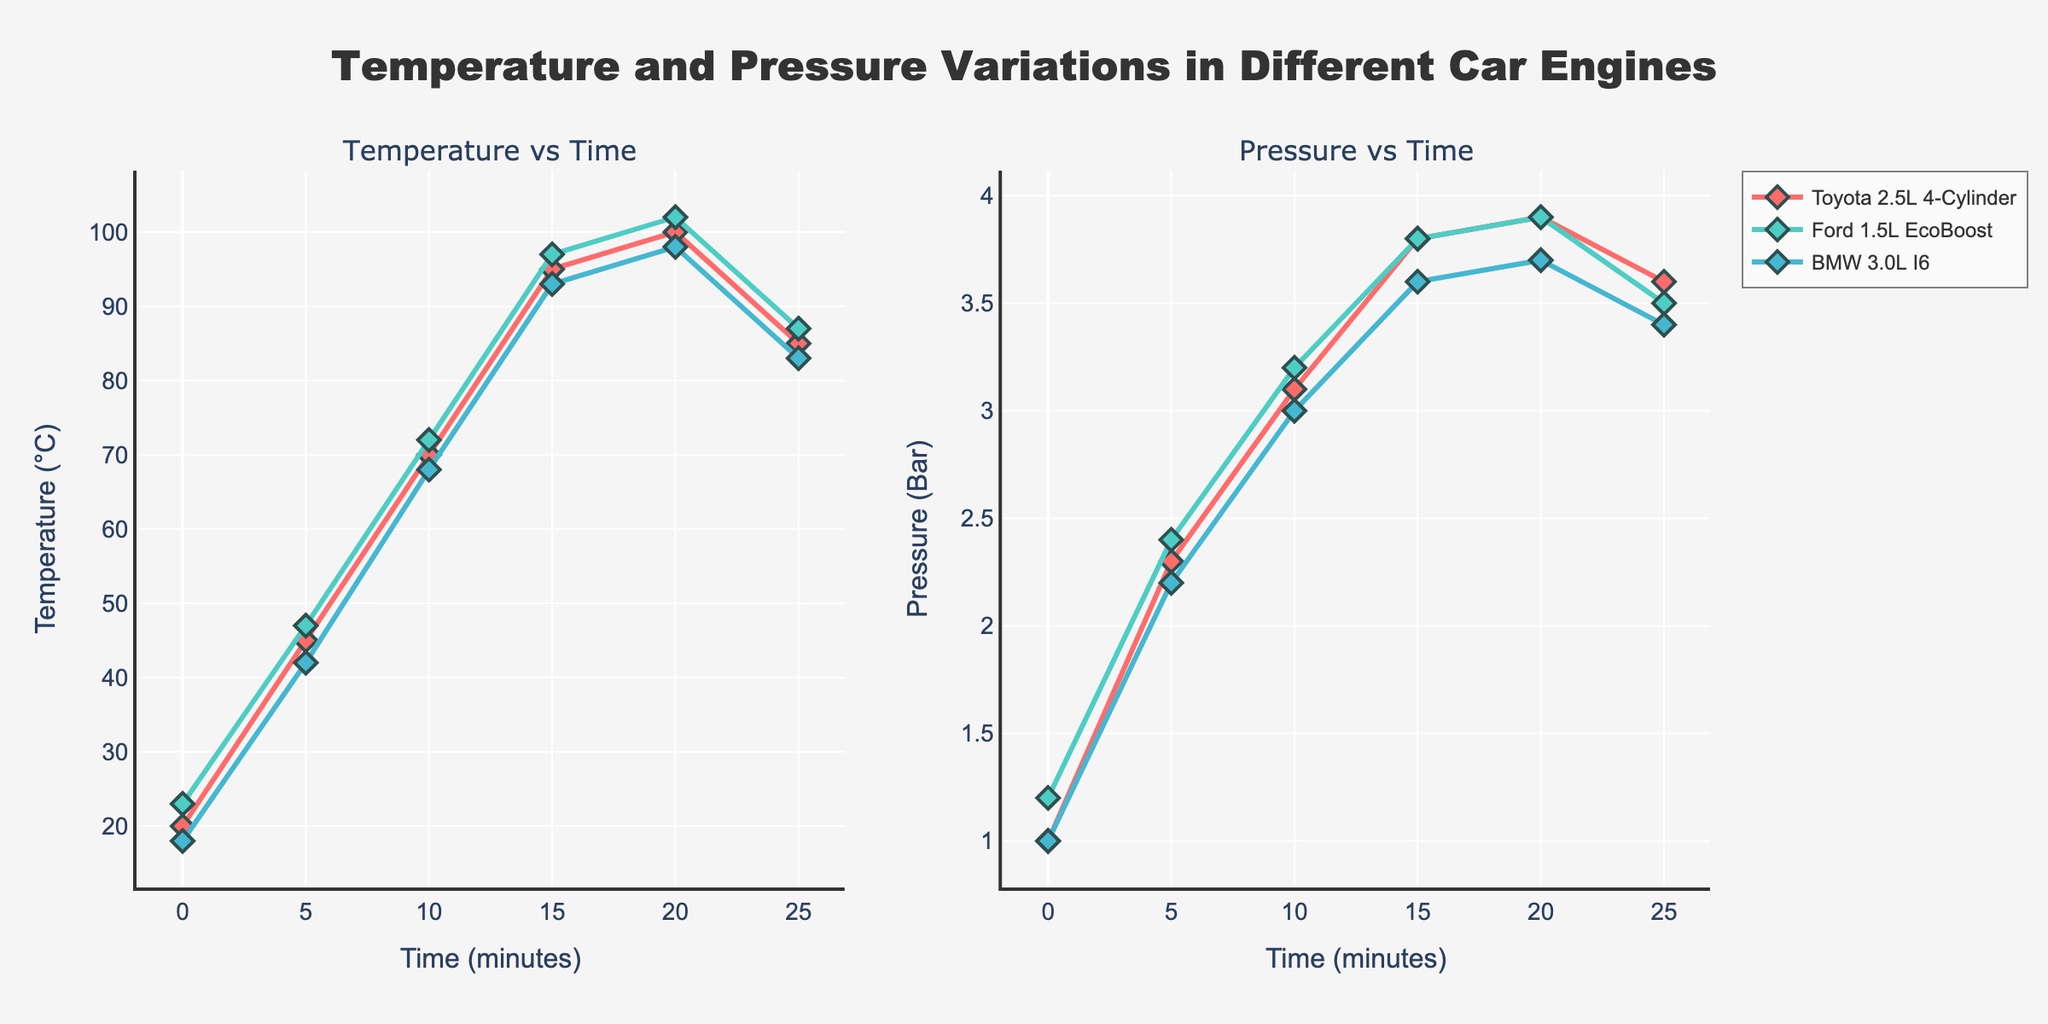What is the title of the figure? The title is usually centered on top of the figure and is shown prominently.
Answer: Temperature and Pressure Variations in Different Car Engines How many car engines are compared in the figure? The legend listed on the right-hand side of the plot indicates the different car engines.
Answer: 3 Which engine reaches the highest temperature at the 20-minute mark? By looking at the "Temperature vs Time" subplot and identifying the data points at 20 minutes, you can find the highest value.
Answer: Ford 1.5L EcoBoost At what time does the pressure start to decline for the Toyota 2.5L 4-Cylinder engine? Looking at the "Pressure vs Time" subplot, find where the pressure line starts to decrease after an increase.
Answer: 20 minutes Between minutes 15 to 20, which engine shows the least change in temperature? Examine the "Temperature vs Time" subplot, compare the temperatures at 15 and 20 minutes for all engines, and calculate the differences.
Answer: BMW 3.0L I6 What is the initial pressure for the BMW 3.0L I6 engine? Check the "Pressure vs Time" subplot for the initial pressure value at 0 minutes for the BMW engine.
Answer: 1.0 Bar Which engine shows the sharpest increase in temperature from 0 to 5 minutes? Compare the slopes of the temperature lines from 0 to 5 minutes for all engines.
Answer: Toyota 2.5L 4-Cylinder How does the maximum pressure of the Ford 1.5L EcoBoost compare to that of the BMW 3.0L I6? Look at the "Pressure vs Time" subplot to determine the maximum pressure values for both engines and compare them.
Answer: They are the same What is the temperature difference for the Toyota 2.5L 4-Cylinder between 10 and 25 minutes? Subtract the temperature at 25 minutes from the temperature at 10 minutes for the Toyota engine.
Answer: 85 - 70 = 15°C At what time do all engines show their peak temperature? Look at the "Temperature vs Time" subplot and identify the time point for all engines where they reach their highest temperature.
Answer: 20 minutes 